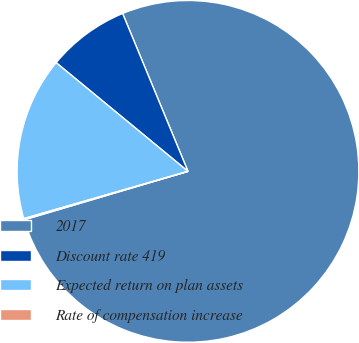Convert chart to OTSL. <chart><loc_0><loc_0><loc_500><loc_500><pie_chart><fcel>2017<fcel>Discount rate 419<fcel>Expected return on plan assets<fcel>Rate of compensation increase<nl><fcel>76.67%<fcel>7.78%<fcel>15.43%<fcel>0.12%<nl></chart> 